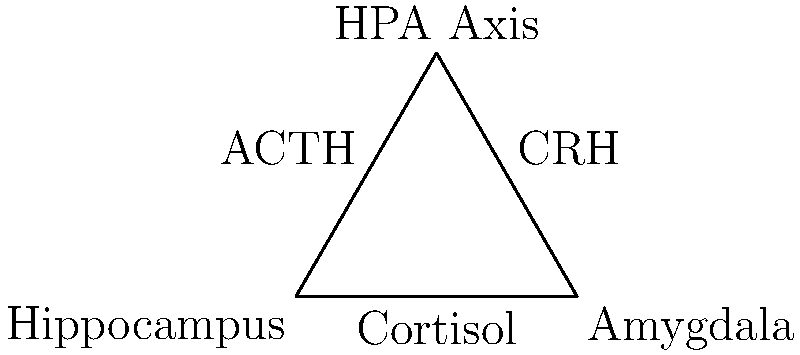In this diagram representing the brain's stress response system, which component is responsible for the initial detection and processing of stress-related stimuli, often associated with emotional memories? To answer this question, let's break down the key components of the brain's stress response system as shown in the diagram:

1. Hippocampus: This structure is involved in memory formation and recall, particularly contextual memories related to stress.

2. Amygdala: This is the component responsible for the initial detection and processing of stress-related stimuli. It's closely associated with emotional memories and the fear response.

3. HPA Axis (Hypothalamic-Pituitary-Adrenal Axis): This is the central stress response system that coordinates the body's reaction to stress.

4. Cortisol: This is the primary stress hormone released by the adrenal glands as part of the stress response.

5. ACTH (Adrenocorticotropic Hormone): This hormone is released by the pituitary gland and stimulates the production of cortisol.

6. CRH (Corticotropin-Releasing Hormone): This hormone is released by the hypothalamus and triggers the release of ACTH.

Among these components, the Amygdala is specifically responsible for the initial detection and processing of stress-related stimuli. It plays a crucial role in emotional processing, particularly fear and anxiety responses. When a potentially threatening stimulus is detected, the amygdala rapidly processes this information and initiates the stress response cascade, including the activation of the HPA axis.

For veterans with mental health conditions, understanding the role of the amygdala is particularly important. Many trauma-related disorders, such as Post-Traumatic Stress Disorder (PTSD), involve heightened amygdala activity, leading to exaggerated stress responses and emotional reactivity.
Answer: Amygdala 